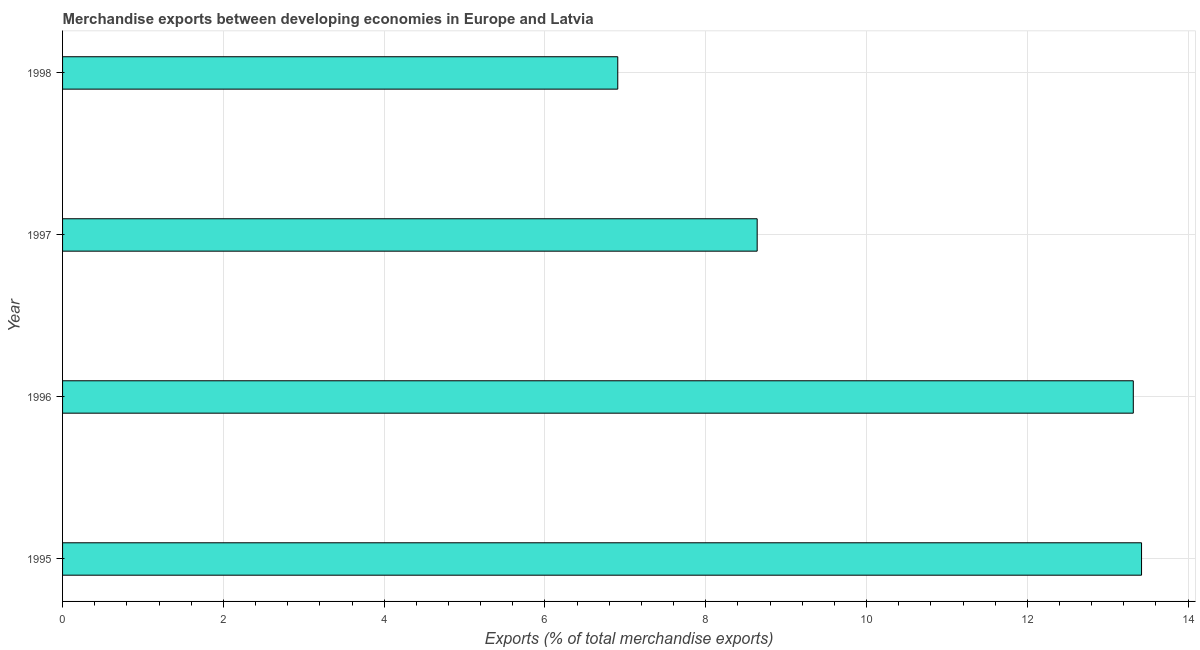What is the title of the graph?
Offer a terse response. Merchandise exports between developing economies in Europe and Latvia. What is the label or title of the X-axis?
Provide a succinct answer. Exports (% of total merchandise exports). What is the label or title of the Y-axis?
Your answer should be very brief. Year. What is the merchandise exports in 1997?
Provide a succinct answer. 8.64. Across all years, what is the maximum merchandise exports?
Give a very brief answer. 13.42. Across all years, what is the minimum merchandise exports?
Provide a short and direct response. 6.91. In which year was the merchandise exports minimum?
Your answer should be compact. 1998. What is the sum of the merchandise exports?
Provide a succinct answer. 42.28. What is the difference between the merchandise exports in 1997 and 1998?
Offer a very short reply. 1.73. What is the average merchandise exports per year?
Your response must be concise. 10.57. What is the median merchandise exports?
Ensure brevity in your answer.  10.98. Is the merchandise exports in 1995 less than that in 1998?
Give a very brief answer. No. Is the difference between the merchandise exports in 1995 and 1996 greater than the difference between any two years?
Your answer should be very brief. No. What is the difference between the highest and the second highest merchandise exports?
Ensure brevity in your answer.  0.1. Is the sum of the merchandise exports in 1997 and 1998 greater than the maximum merchandise exports across all years?
Your answer should be compact. Yes. What is the difference between the highest and the lowest merchandise exports?
Your response must be concise. 6.51. How many bars are there?
Give a very brief answer. 4. Are all the bars in the graph horizontal?
Provide a short and direct response. Yes. How many years are there in the graph?
Ensure brevity in your answer.  4. What is the difference between two consecutive major ticks on the X-axis?
Ensure brevity in your answer.  2. What is the Exports (% of total merchandise exports) in 1995?
Provide a succinct answer. 13.42. What is the Exports (% of total merchandise exports) of 1996?
Offer a terse response. 13.32. What is the Exports (% of total merchandise exports) in 1997?
Give a very brief answer. 8.64. What is the Exports (% of total merchandise exports) in 1998?
Make the answer very short. 6.91. What is the difference between the Exports (% of total merchandise exports) in 1995 and 1996?
Ensure brevity in your answer.  0.1. What is the difference between the Exports (% of total merchandise exports) in 1995 and 1997?
Provide a short and direct response. 4.78. What is the difference between the Exports (% of total merchandise exports) in 1995 and 1998?
Your response must be concise. 6.51. What is the difference between the Exports (% of total merchandise exports) in 1996 and 1997?
Provide a succinct answer. 4.68. What is the difference between the Exports (% of total merchandise exports) in 1996 and 1998?
Provide a short and direct response. 6.41. What is the difference between the Exports (% of total merchandise exports) in 1997 and 1998?
Give a very brief answer. 1.73. What is the ratio of the Exports (% of total merchandise exports) in 1995 to that in 1997?
Provide a succinct answer. 1.55. What is the ratio of the Exports (% of total merchandise exports) in 1995 to that in 1998?
Your answer should be very brief. 1.94. What is the ratio of the Exports (% of total merchandise exports) in 1996 to that in 1997?
Make the answer very short. 1.54. What is the ratio of the Exports (% of total merchandise exports) in 1996 to that in 1998?
Give a very brief answer. 1.93. What is the ratio of the Exports (% of total merchandise exports) in 1997 to that in 1998?
Make the answer very short. 1.25. 